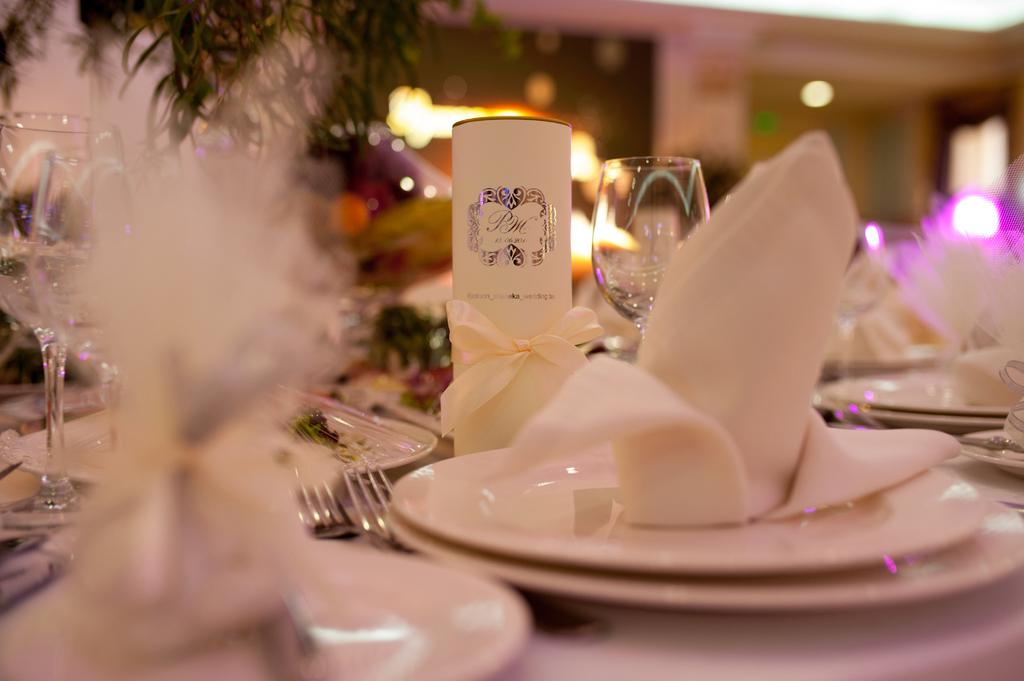What piece of furniture is present in the image? There is a table in the image. What items are placed on the table? There are plates, forks, and glasses on the table. What additional items are on the plates? There are tissue papers on the plates. What can be seen in the background of the image? There are lights visible in the background of the image. How much income does the person wearing jeans in the image earn? There is no person wearing jeans in the image, and therefore no information about their income can be provided. 